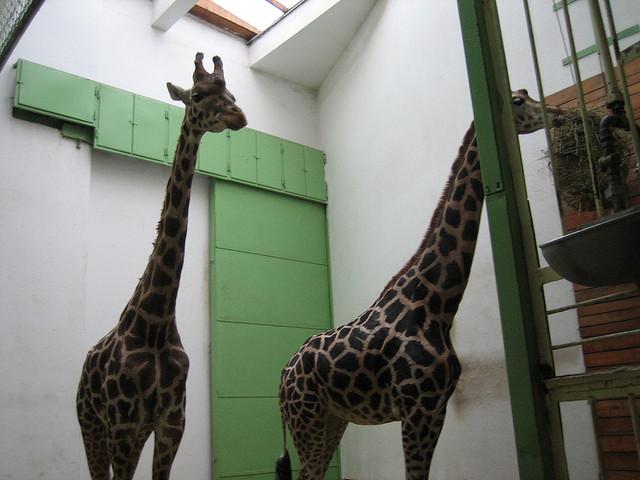Are these giraffes lying down?
Keep it brief. No. Are the giraffes in the wild?
Write a very short answer. No. Are both giraffes eating?
Write a very short answer. No. Is this room ventilated?
Quick response, please. Yes. 